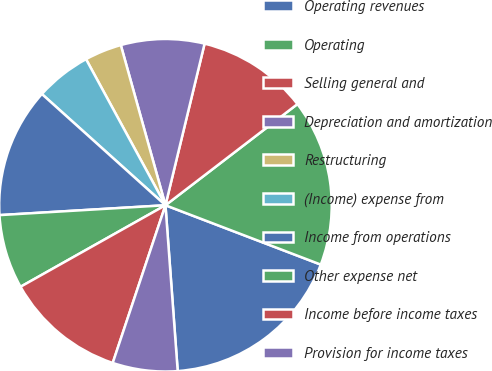<chart> <loc_0><loc_0><loc_500><loc_500><pie_chart><fcel>Operating revenues<fcel>Operating<fcel>Selling general and<fcel>Depreciation and amortization<fcel>Restructuring<fcel>(Income) expense from<fcel>Income from operations<fcel>Other expense net<fcel>Income before income taxes<fcel>Provision for income taxes<nl><fcel>18.02%<fcel>16.22%<fcel>10.81%<fcel>8.11%<fcel>3.6%<fcel>5.41%<fcel>12.61%<fcel>7.21%<fcel>11.71%<fcel>6.31%<nl></chart> 